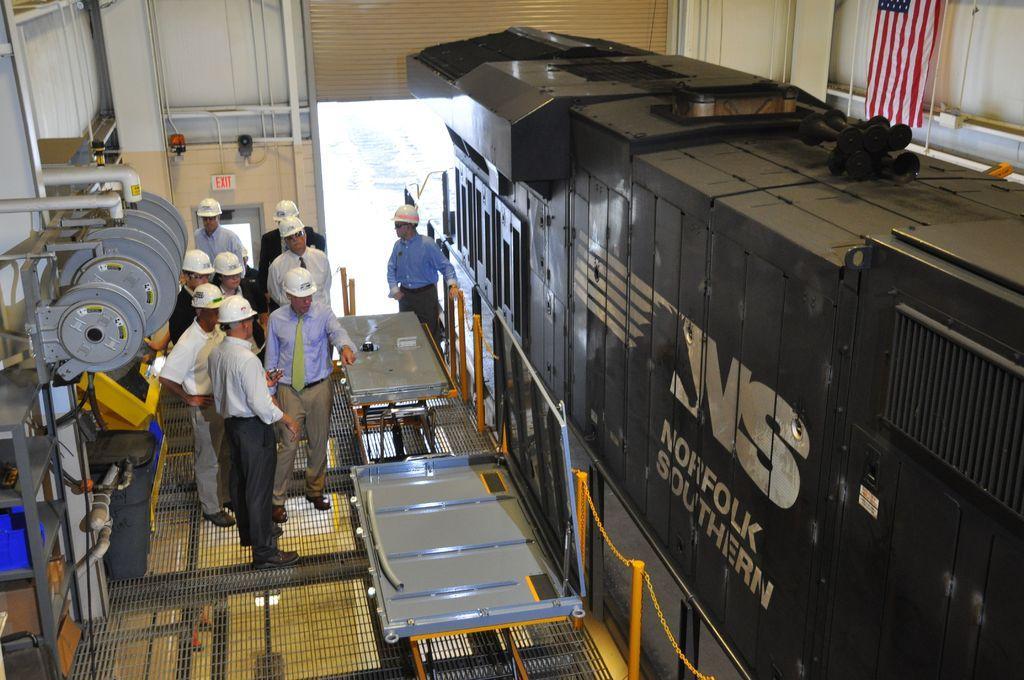In one or two sentences, can you explain what this image depicts? In this image I can see on the left side a group of people are there, they wore helmets, trousers, ties, shirts. On the right side there is a rail engine in grey color 